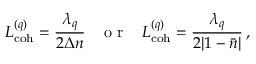<formula> <loc_0><loc_0><loc_500><loc_500>L _ { c o h } ^ { ( q ) } = \frac { \lambda _ { q } } { 2 \Delta n } \, o r \, L _ { c o h } ^ { ( q ) } = \frac { \lambda _ { q } } { 2 | 1 - \bar { n } | } \, ,</formula> 